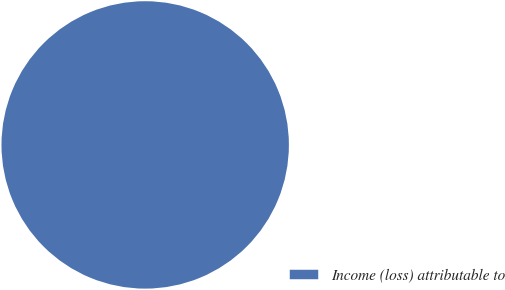Convert chart to OTSL. <chart><loc_0><loc_0><loc_500><loc_500><pie_chart><fcel>Income (loss) attributable to<nl><fcel>100.0%<nl></chart> 